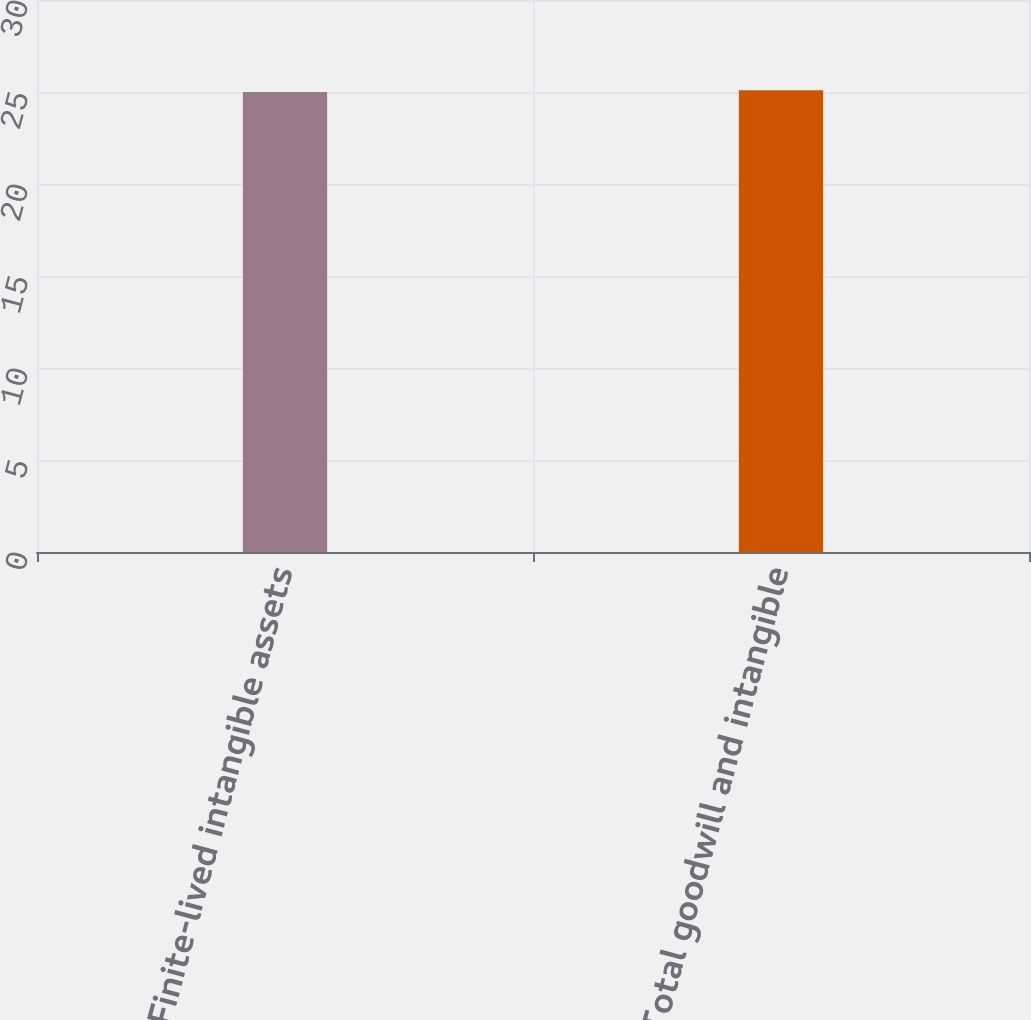<chart> <loc_0><loc_0><loc_500><loc_500><bar_chart><fcel>Finite-lived intangible assets<fcel>Total goodwill and intangible<nl><fcel>25<fcel>25.1<nl></chart> 